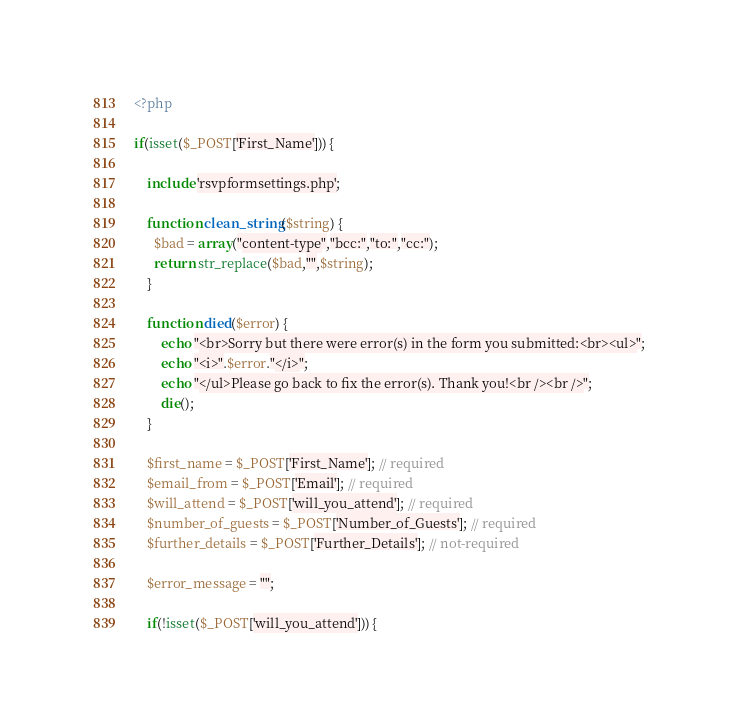<code> <loc_0><loc_0><loc_500><loc_500><_PHP_><?php

if(isset($_POST['First_Name'])) {
	
	include 'rsvpformsettings.php';

	function clean_string($string) {
	  $bad = array("content-type","bcc:","to:","cc:");
	  return str_replace($bad,"",$string);
	}
	
	function died($error) {
		echo "<br>Sorry but there were error(s) in the form you submitted:<br><ul>";
		echo "<i>".$error."</i>";
		echo "</ul>Please go back to fix the error(s). Thank you!<br /><br />";
		die();
	}
	
	$first_name = $_POST['First_Name']; // required
	$email_from = $_POST['Email']; // required
	$will_attend = $_POST['will_you_attend']; // required
	$number_of_guests = $_POST['Number_of_Guests']; // required
	$further_details = $_POST['Further_Details']; // not-required
	
	$error_message = "";
	
	if(!isset($_POST['will_you_attend'])) {</code> 